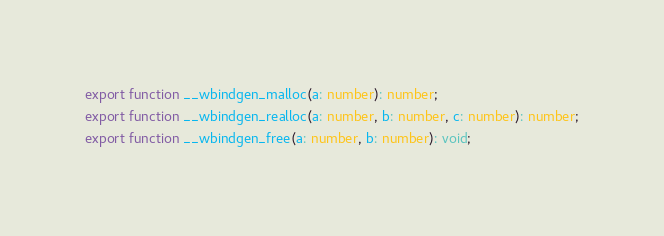Convert code to text. <code><loc_0><loc_0><loc_500><loc_500><_TypeScript_>export function __wbindgen_malloc(a: number): number;
export function __wbindgen_realloc(a: number, b: number, c: number): number;
export function __wbindgen_free(a: number, b: number): void;
</code> 